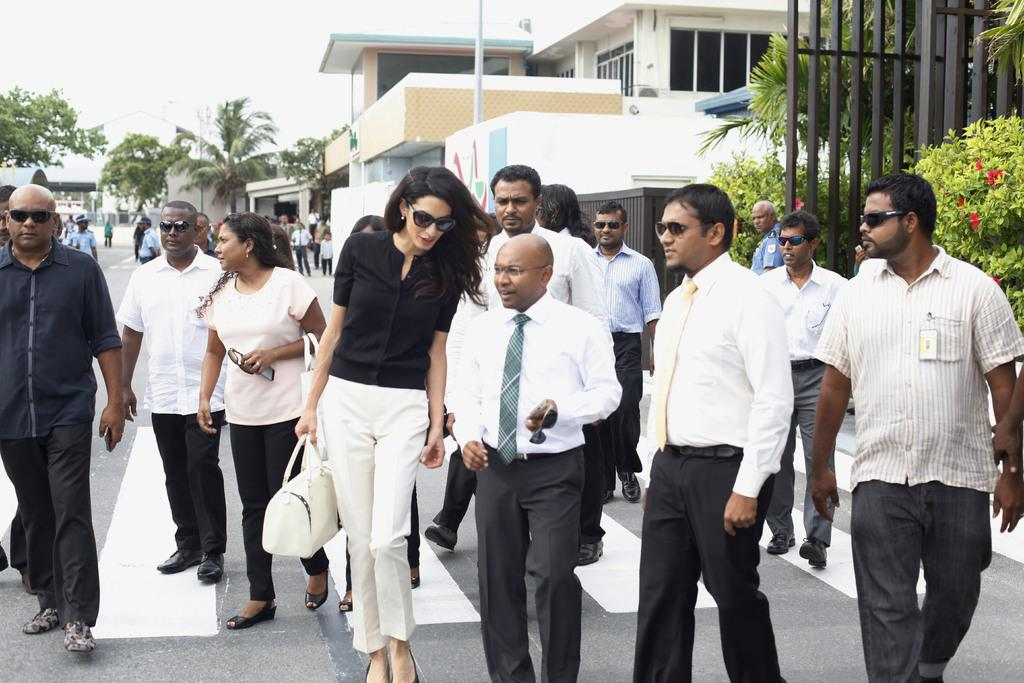What are the people in the image doing? The people in the image are standing and walking. What can be seen behind the people? There are trees behind the people. What other objects are visible in the image? There are poles visible in the image. What is visible in the background of the image? There are buildings in the background. What is visible at the top of the image? The sky is visible at the top of the image. Can you tell me how many hens are walking with the people in the image? There are no hens present in the image; it features people standing and walking, trees, poles, buildings, and the sky. 